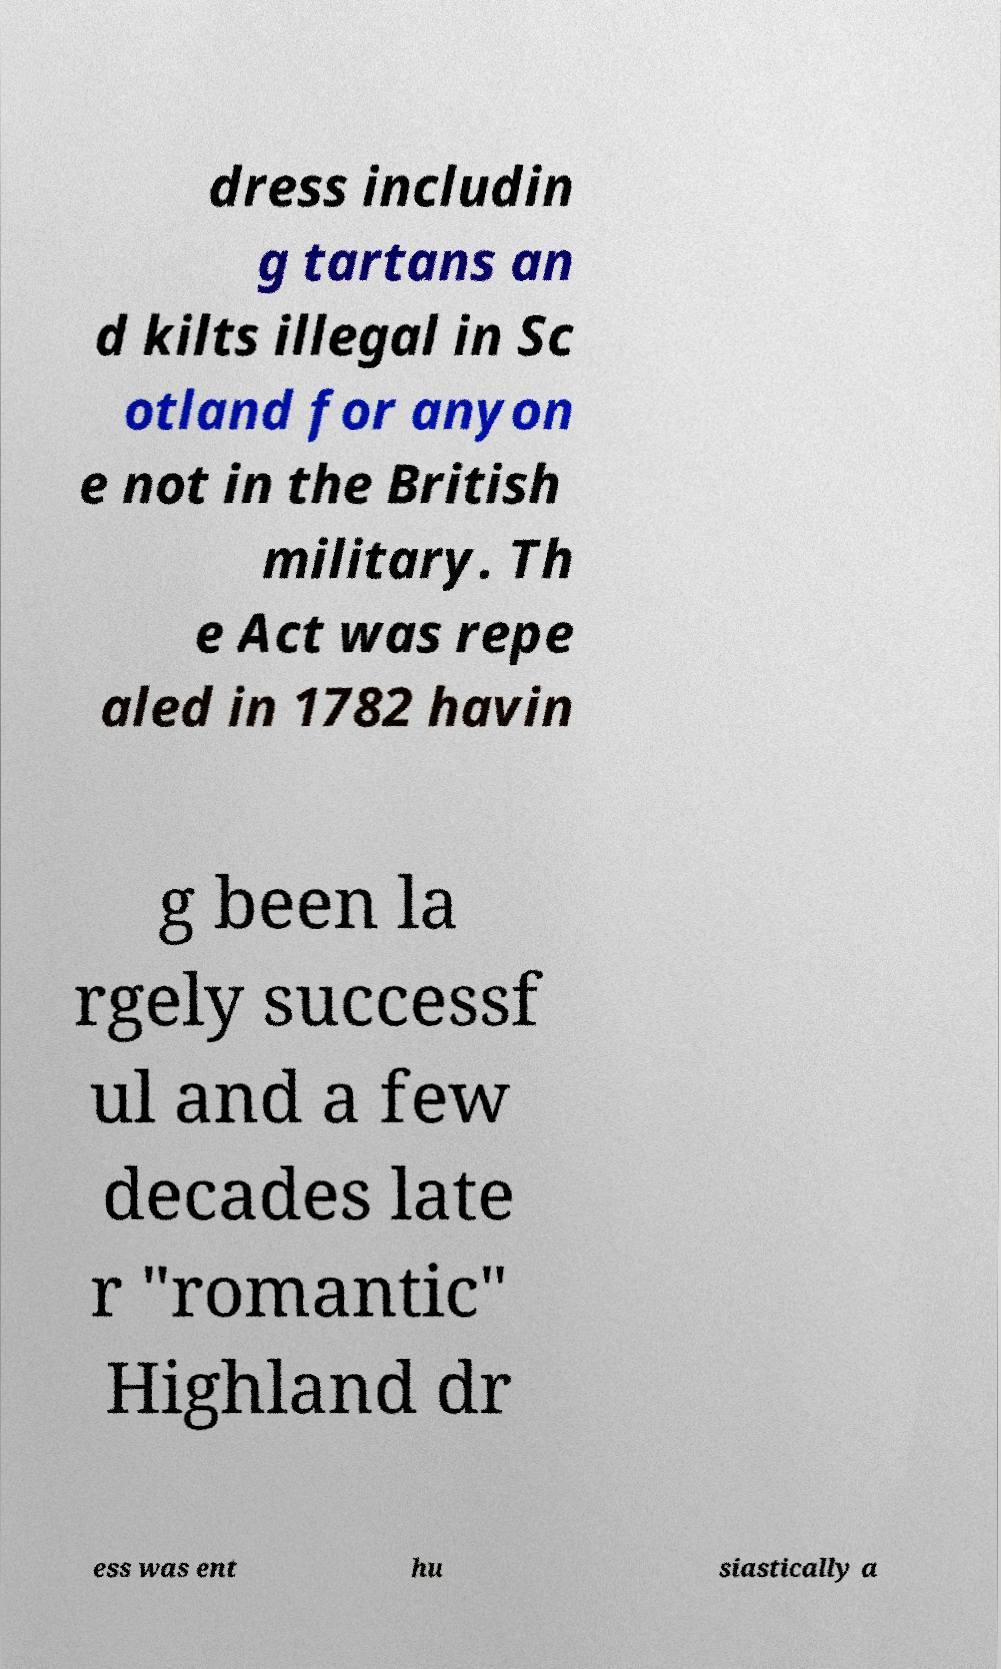Can you accurately transcribe the text from the provided image for me? dress includin g tartans an d kilts illegal in Sc otland for anyon e not in the British military. Th e Act was repe aled in 1782 havin g been la rgely successf ul and a few decades late r "romantic" Highland dr ess was ent hu siastically a 